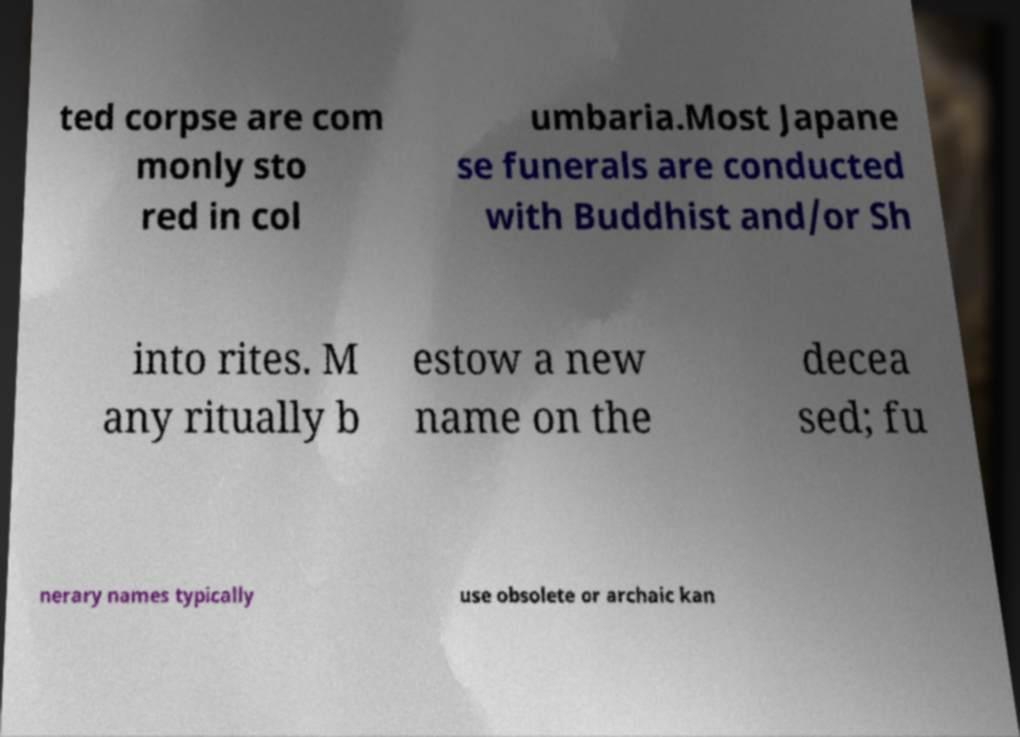Can you accurately transcribe the text from the provided image for me? ted corpse are com monly sto red in col umbaria.Most Japane se funerals are conducted with Buddhist and/or Sh into rites. M any ritually b estow a new name on the decea sed; fu nerary names typically use obsolete or archaic kan 